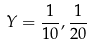Convert formula to latex. <formula><loc_0><loc_0><loc_500><loc_500>Y = \frac { 1 } { 1 0 } , \frac { 1 } { 2 0 }</formula> 